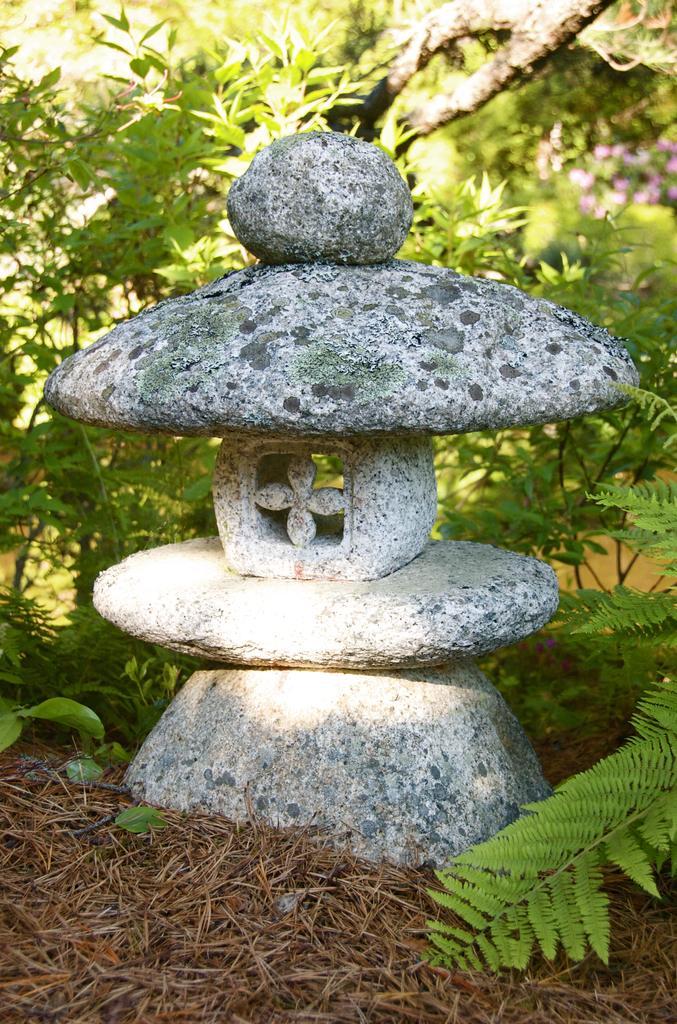Could you give a brief overview of what you see in this image? In this image we can see a few stones which are in different sizes. There stones are placed one on another. There are many plants and a tree. There are many flowers to a plant at the right side of the image. There is a dry grass at the bottom of the image. 